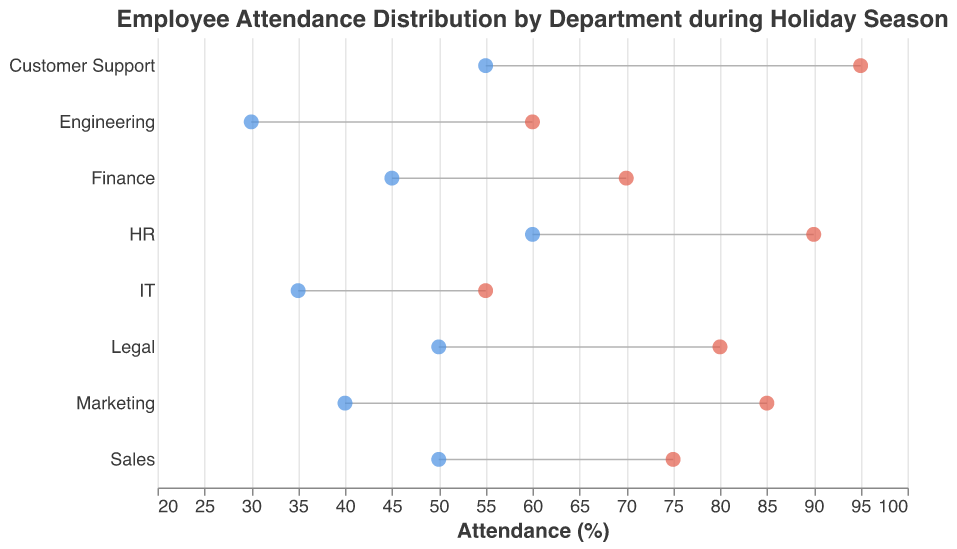What is the minimum attendance percentage for the IT department? The minimum attendance percentage for each department is represented by the left point of the horizontal lines. For the IT department, this point is located at 35%.
Answer: 35% Which department had the highest maximum attendance? The maximum attendance percentage is represented by the right point of the horizontal lines. The Customer Support department has the highest point at 95%.
Answer: Customer Support What is the difference between the maximum and minimum attendance in the HR department? For the HR department, the maximum attendance is 90% and the minimum attendance is 60%. The difference is calculated as 90% - 60% = 30%.
Answer: 30% How many departments have a minimum attendance greater than or equal to 50%? Counting the departments whose minimum attendance point is at or above 50%: Sales, Customer Support, HR, and Legal. Hence there are 4 departments.
Answer: 4 Comparing Finance and Engineering, which department had a higher minimum attendance? Comparing the left points of the horizontal lines for Finance and Engineering, we see Finance has 45% and Engineering has 30%. Finance has a higher minimum attendance.
Answer: Finance What is the range of attendance for the Legal department? The range is calculated as the difference between the maximum and minimum attendance. For the Legal department, it is 80% - 50% = 30%.
Answer: 30% Which department had the narrowest range of attendance percentages? By comparing the differences between the maximum and minimum attendances for each department, we see that IT has the narrowest range: 55% - 35% = 20%.
Answer: IT What is the average of the minimum attendance values across all departments? Sum the minimum attendance values of all departments and divide by the number of departments. (50 + 40 + 30 + 55 + 60 + 45 + 35 + 50) / 8 = 365 / 8 = 45.625%.
Answer: 45.625% Based on the chart, which department appears to have the most reliable attendance (smallest variability)? The smallest variability can be observed from the narrowest range between maximum and minimum attendance values. IT has the smallest range of 20%.
Answer: IT 